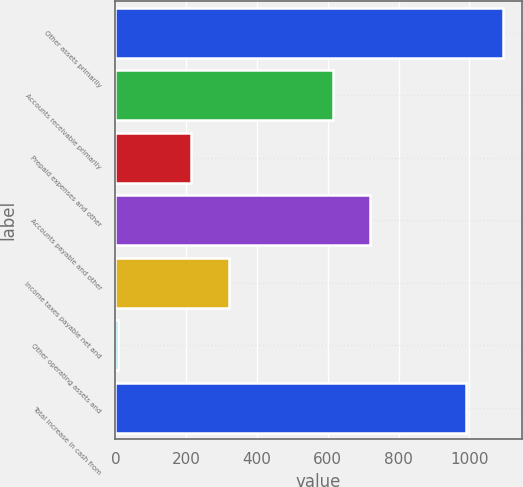Convert chart. <chart><loc_0><loc_0><loc_500><loc_500><bar_chart><fcel>Other assets primarily<fcel>Accounts receivable primarily<fcel>Prepaid expenses and other<fcel>Accounts payable and other<fcel>Income taxes payable net and<fcel>Other operating assets and<fcel>Total increase in cash from<nl><fcel>1093.6<fcel>615<fcel>215<fcel>719.6<fcel>319.6<fcel>8<fcel>989<nl></chart> 